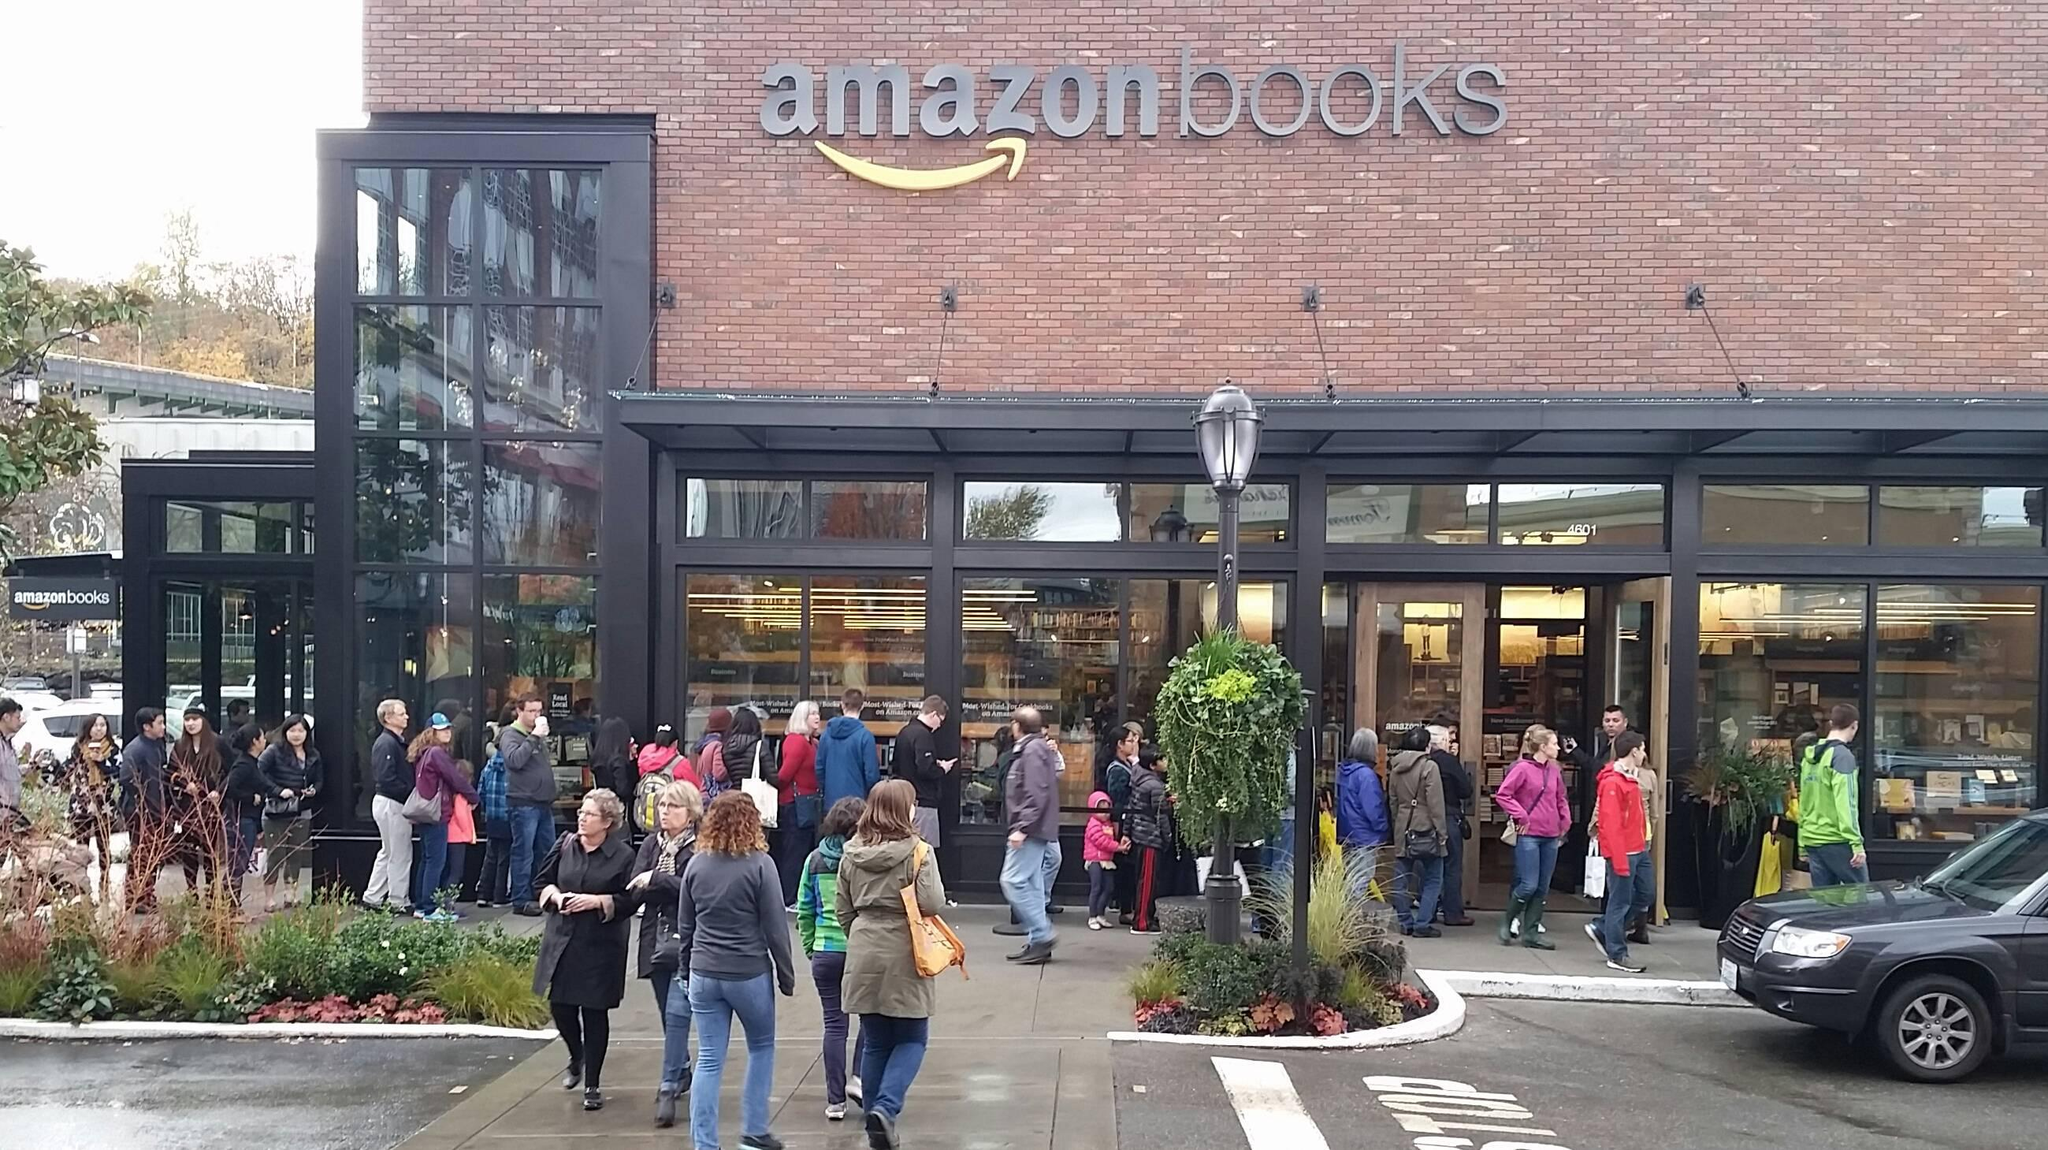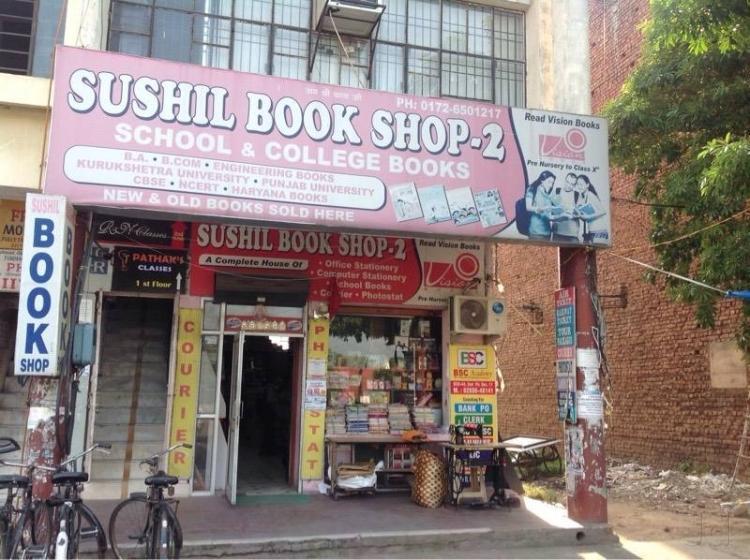The first image is the image on the left, the second image is the image on the right. Considering the images on both sides, is "A person is sitting on the ground in front of a store in the right image." valid? Answer yes or no. No. The first image is the image on the left, the second image is the image on the right. Analyze the images presented: Is the assertion "No people are shown in front of the bookshop in the image on the right." valid? Answer yes or no. Yes. 